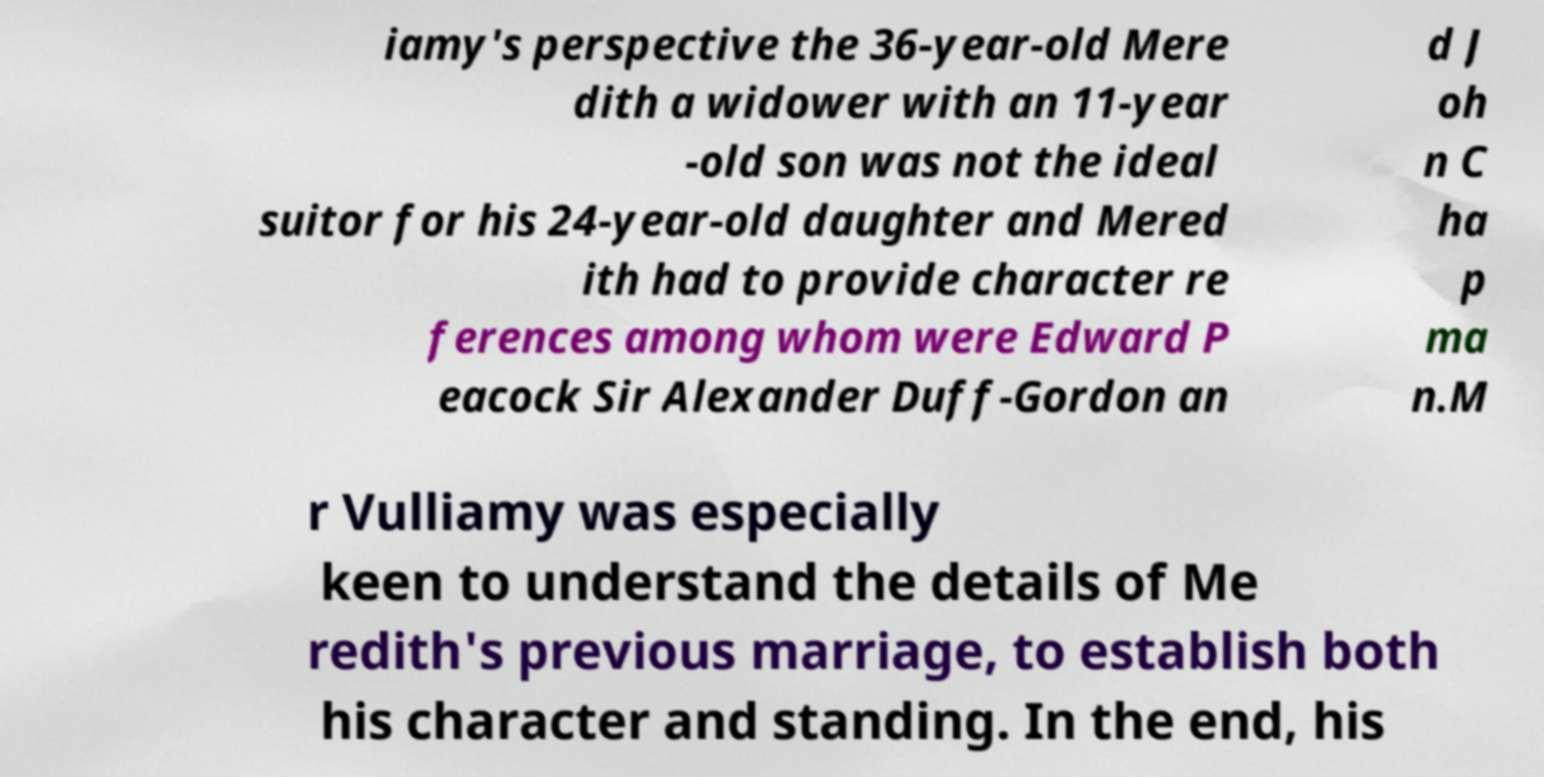There's text embedded in this image that I need extracted. Can you transcribe it verbatim? iamy's perspective the 36-year-old Mere dith a widower with an 11-year -old son was not the ideal suitor for his 24-year-old daughter and Mered ith had to provide character re ferences among whom were Edward P eacock Sir Alexander Duff-Gordon an d J oh n C ha p ma n.M r Vulliamy was especially keen to understand the details of Me redith's previous marriage, to establish both his character and standing. In the end, his 